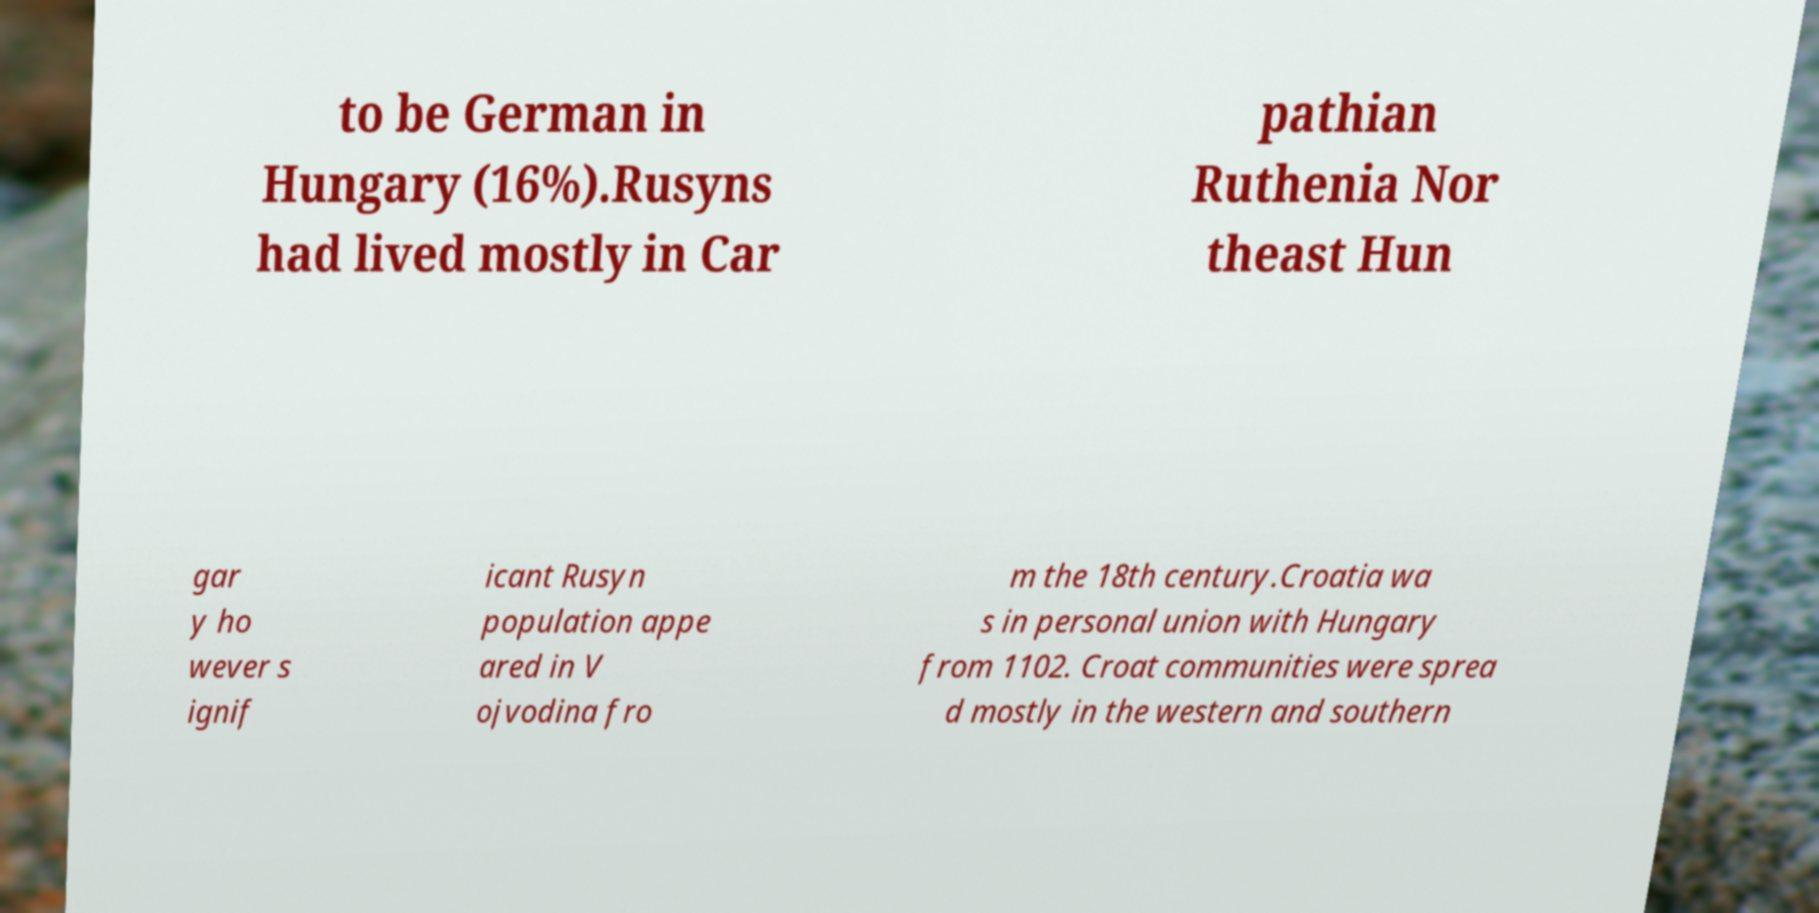There's text embedded in this image that I need extracted. Can you transcribe it verbatim? to be German in Hungary (16%).Rusyns had lived mostly in Car pathian Ruthenia Nor theast Hun gar y ho wever s ignif icant Rusyn population appe ared in V ojvodina fro m the 18th century.Croatia wa s in personal union with Hungary from 1102. Croat communities were sprea d mostly in the western and southern 